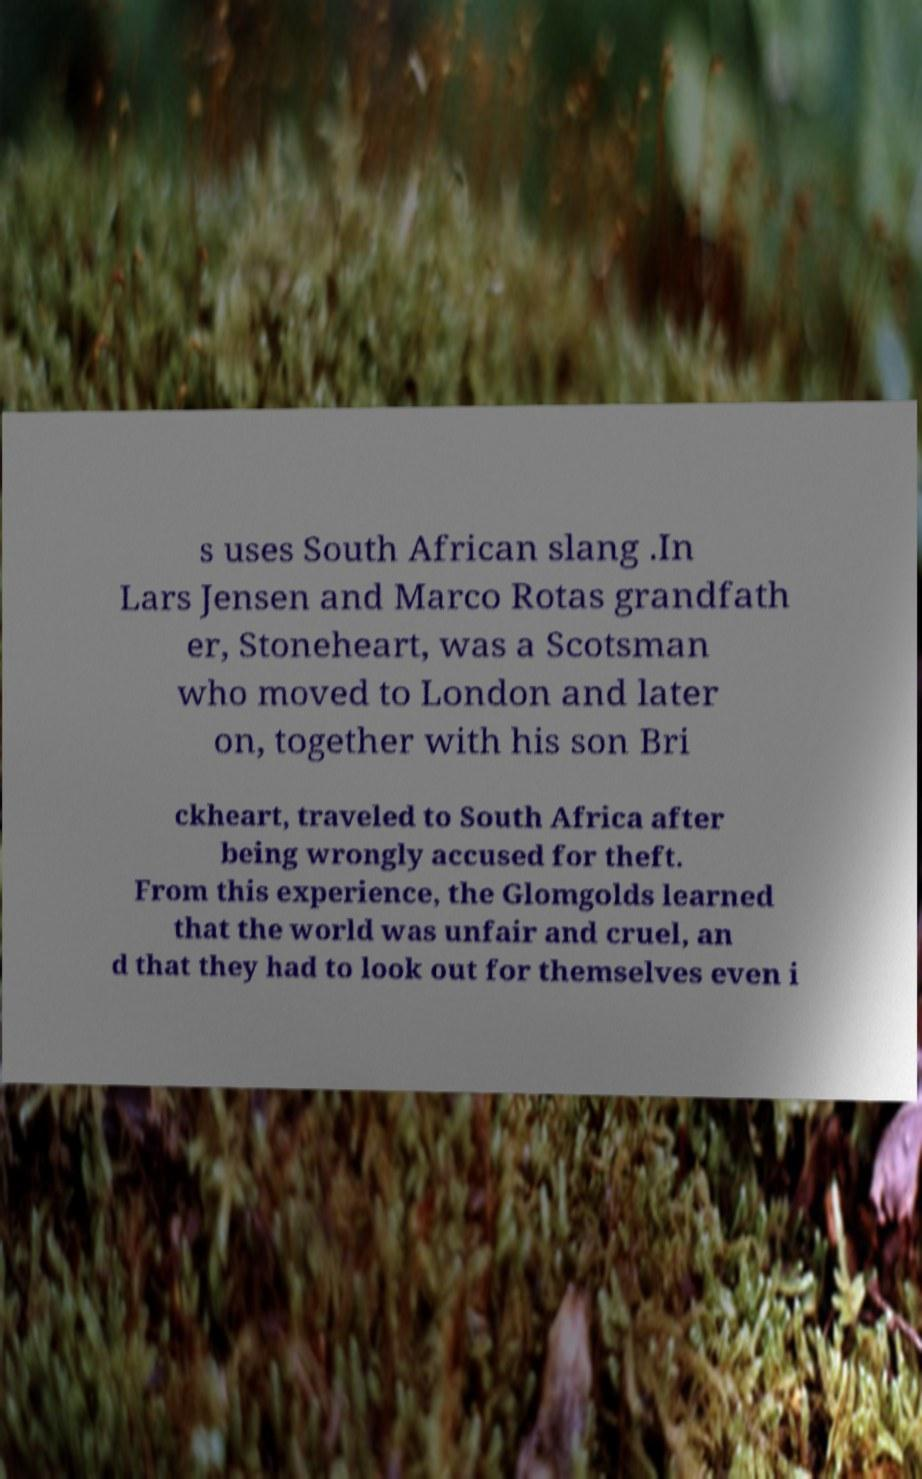Could you extract and type out the text from this image? s uses South African slang .In Lars Jensen and Marco Rotas grandfath er, Stoneheart, was a Scotsman who moved to London and later on, together with his son Bri ckheart, traveled to South Africa after being wrongly accused for theft. From this experience, the Glomgolds learned that the world was unfair and cruel, an d that they had to look out for themselves even i 